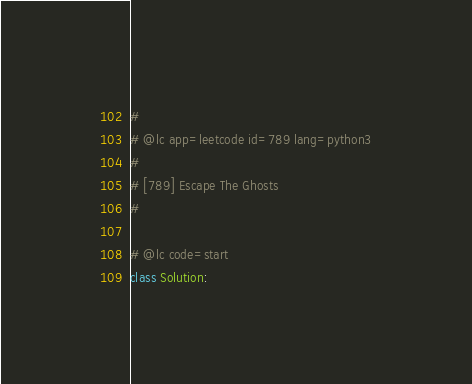Convert code to text. <code><loc_0><loc_0><loc_500><loc_500><_Python_>#
# @lc app=leetcode id=789 lang=python3
#
# [789] Escape The Ghosts
#

# @lc code=start
class Solution:</code> 